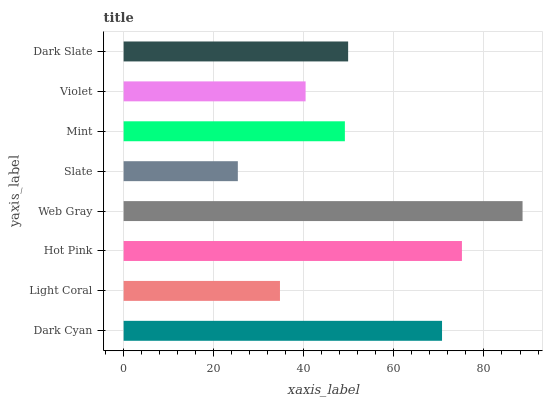Is Slate the minimum?
Answer yes or no. Yes. Is Web Gray the maximum?
Answer yes or no. Yes. Is Light Coral the minimum?
Answer yes or no. No. Is Light Coral the maximum?
Answer yes or no. No. Is Dark Cyan greater than Light Coral?
Answer yes or no. Yes. Is Light Coral less than Dark Cyan?
Answer yes or no. Yes. Is Light Coral greater than Dark Cyan?
Answer yes or no. No. Is Dark Cyan less than Light Coral?
Answer yes or no. No. Is Dark Slate the high median?
Answer yes or no. Yes. Is Mint the low median?
Answer yes or no. Yes. Is Hot Pink the high median?
Answer yes or no. No. Is Dark Slate the low median?
Answer yes or no. No. 